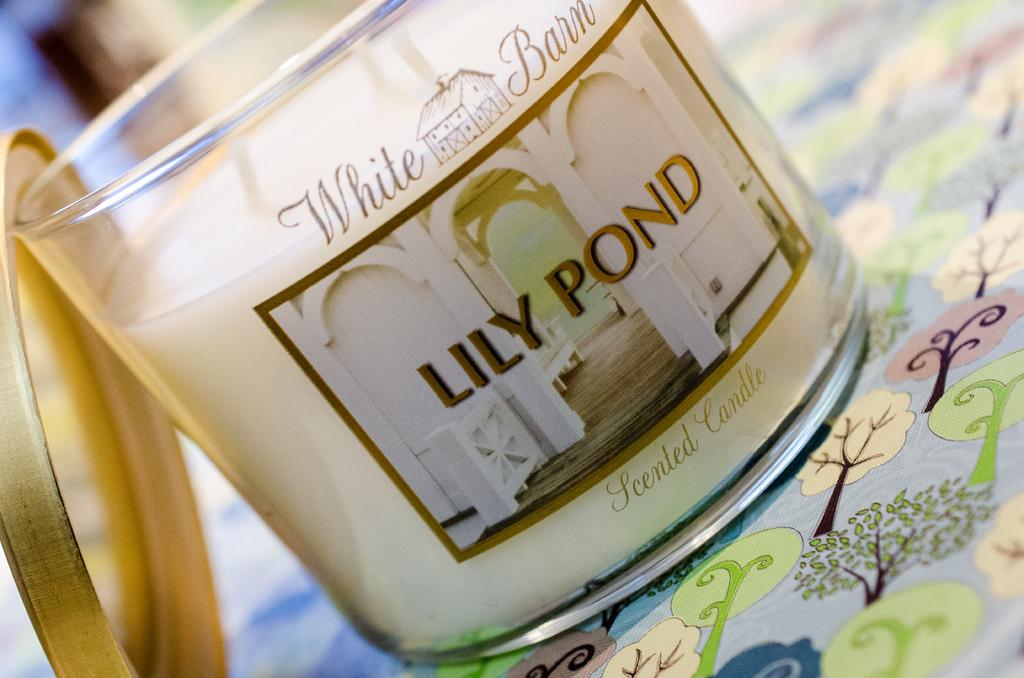<image>
Render a clear and concise summary of the photo. A White Barn brand scented candle in Lily Pond scent. 